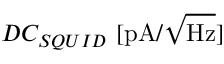Convert formula to latex. <formula><loc_0><loc_0><loc_500><loc_500>D C _ { S Q U I D } \ [ p A / \sqrt { H z } ]</formula> 